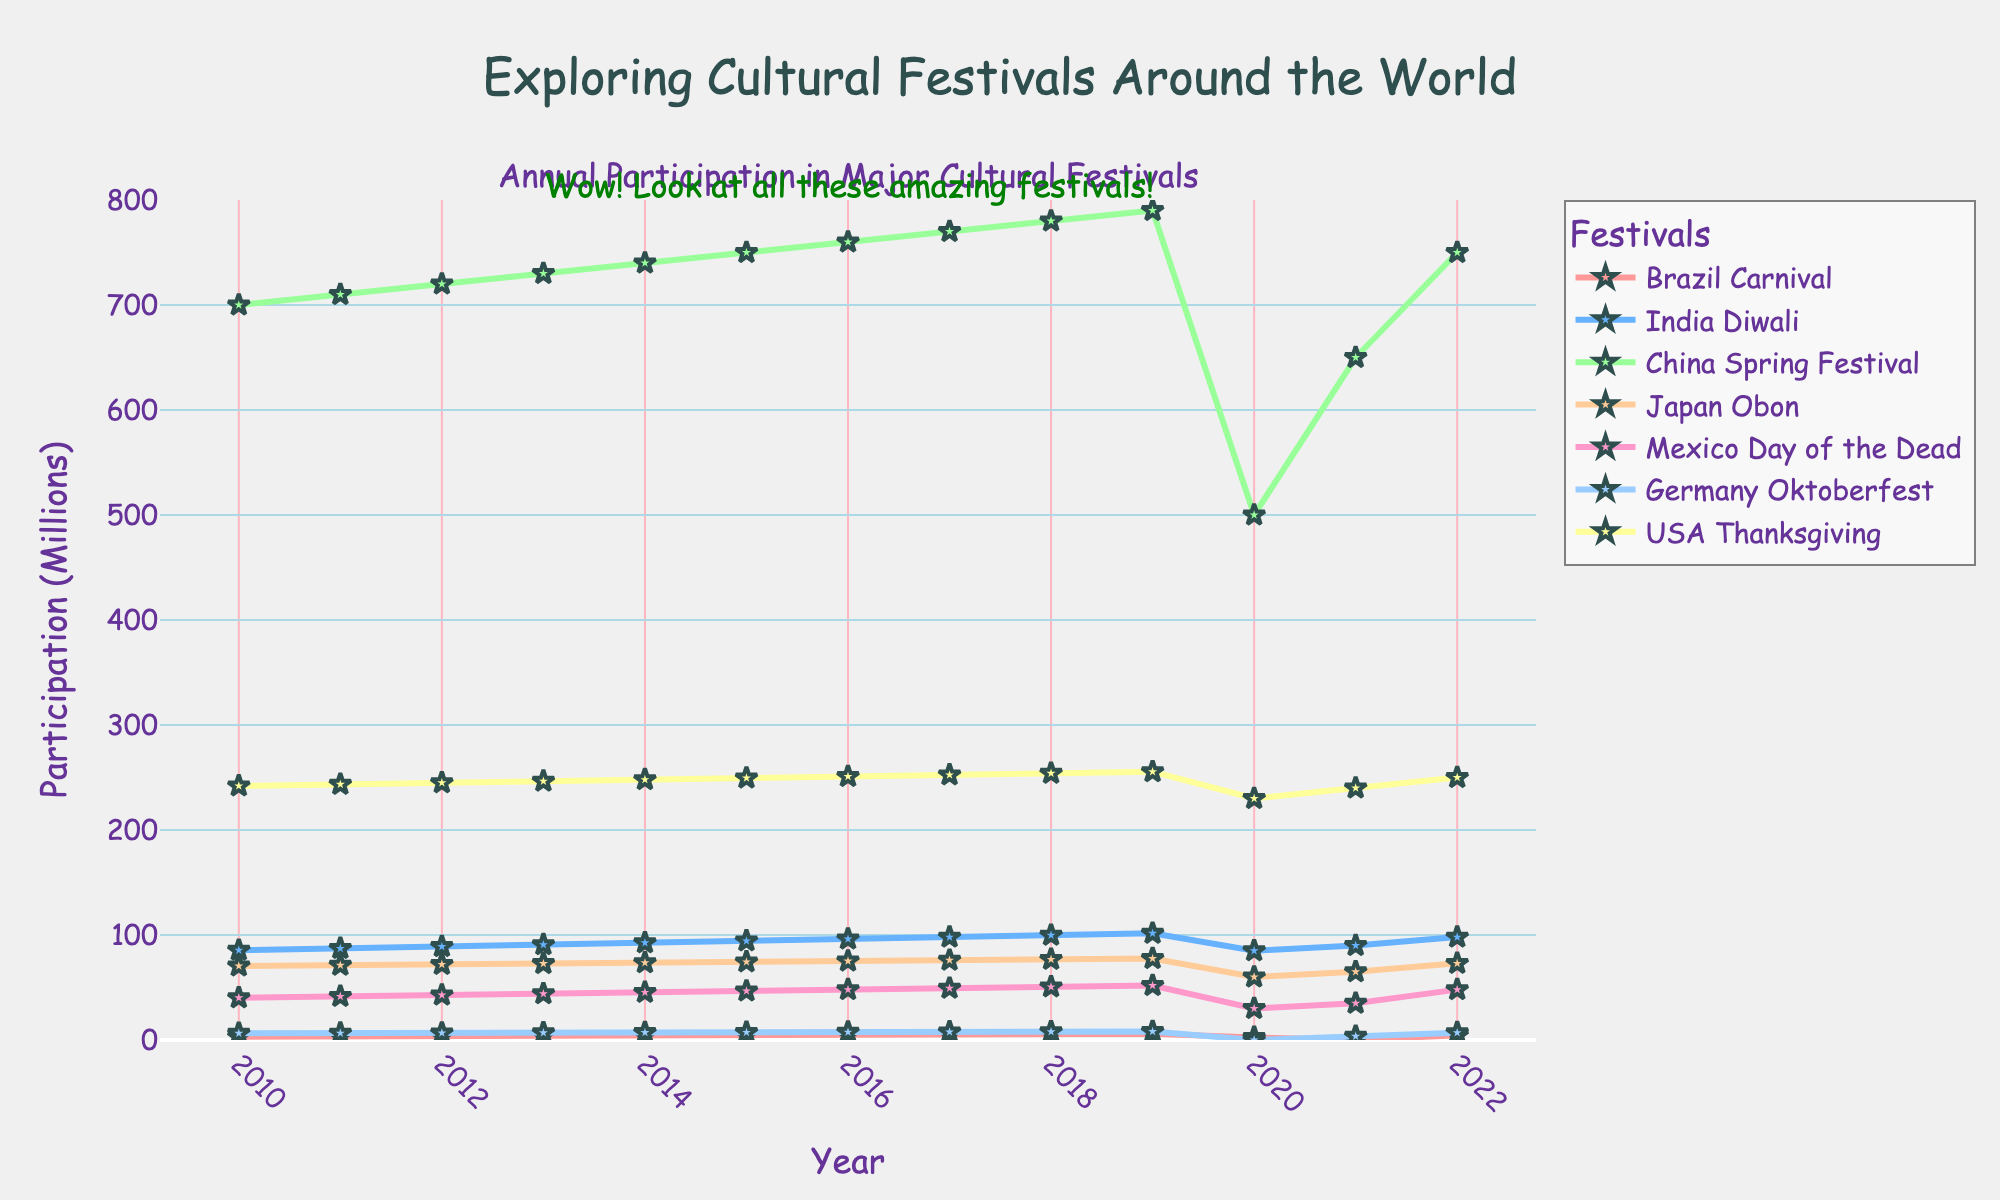What happened to the participation in the Brazil Carnival between 2019 and 2020? In 2019, the participation in the Brazil Carnival was 5.9 million. In 2020, it dropped to 2.5 million. So, the participation decreased significantly.
Answer: It decreased significantly Is the participation in the USA's Thanksgiving festival higher in 2022 than in 2010? In 2010, the participation in USA's Thanksgiving festival was 242 million. In 2022, it was 250 million. Since 250 is greater than 242, the participation increased.
Answer: Yes, it's higher Which festival had the highest participation in 2021? In 2021, the participations are as follows: Brazil Carnival (0 million), India Diwali (90 million), China Spring Festival (650 million), Japan Obon (65 million), Mexico Day of the Dead (35 million), Germany Oktoberfest (3.5 million), USA Thanksgiving (240 million). Among these, the China Spring Festival has the highest value of 650 million.
Answer: China Spring Festival Which festival showed a decrease in participation in 2020 compared to 2019? Comparing the participation in 2019 and 2020 for all festivals: Brazil Carnival (5.9 to 2.5 million), India Diwali (101.6 to 85 million), China Spring Festival (790 to 500 million), Japan Obon (77.6 to 60 million), Mexico Day of the Dead (51.9 to 30 million), Germany Oktoberfest (8.1 to 0 million), USA Thanksgiving (255.5 to 230 million). All these festivals showed a decrease.
Answer: All festivals showed a decrease What is the difference in participation between Brazil Carnival and India Diwali in 2015? In 2015, the participation for Brazil Carnival was 4.7 million and for India Diwali was 94.4 million. The difference is 94.4 - 4.7 = 89.7 million.
Answer: 89.7 million In which year did Germany Oktoberfest have the highest participation and what was it? The highest participation for Germany Oktoberfest is observed in 2019 with 8.1 million participants.
Answer: 2019 with 8.1 million Compare the participation in Mexico Day of the Dead between 2010 and 2021. Which year had higher participation? In 2010, the participation in Mexico Day of the Dead was 40.2 million. In 2021, it was 35 million. Since 40.2 is greater than 35, the participation was higher in 2010.
Answer: 2010 What is the average participation for Japan Obon from 2010 to 2022? The participation values for Japan Obon from 2010 to 2022 are: 70.5, 71.2, 72.0, 72.8, 73.6, 74.4, 75.2, 76.0, 76.8, 77.6, 60.0, 65.0, and 73.0. Summing these values gives 938.1. Dividing by 13 (number of years) results in an average of approximately 72.16 million.
Answer: Approximately 72.16 million 